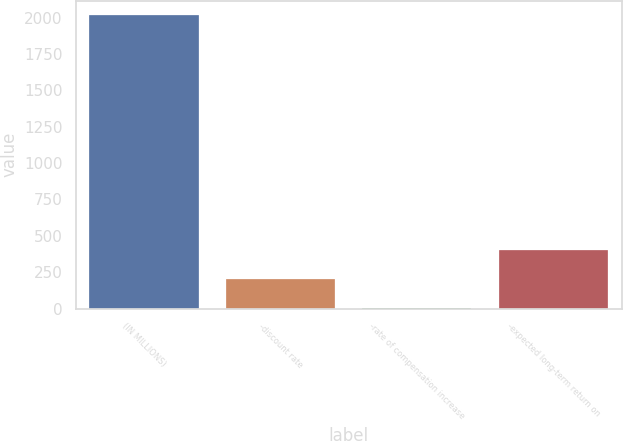<chart> <loc_0><loc_0><loc_500><loc_500><bar_chart><fcel>(IN MILLIONS)<fcel>-discount rate<fcel>-rate of compensation increase<fcel>-expected long-term return on<nl><fcel>2016<fcel>202.68<fcel>1.2<fcel>404.16<nl></chart> 